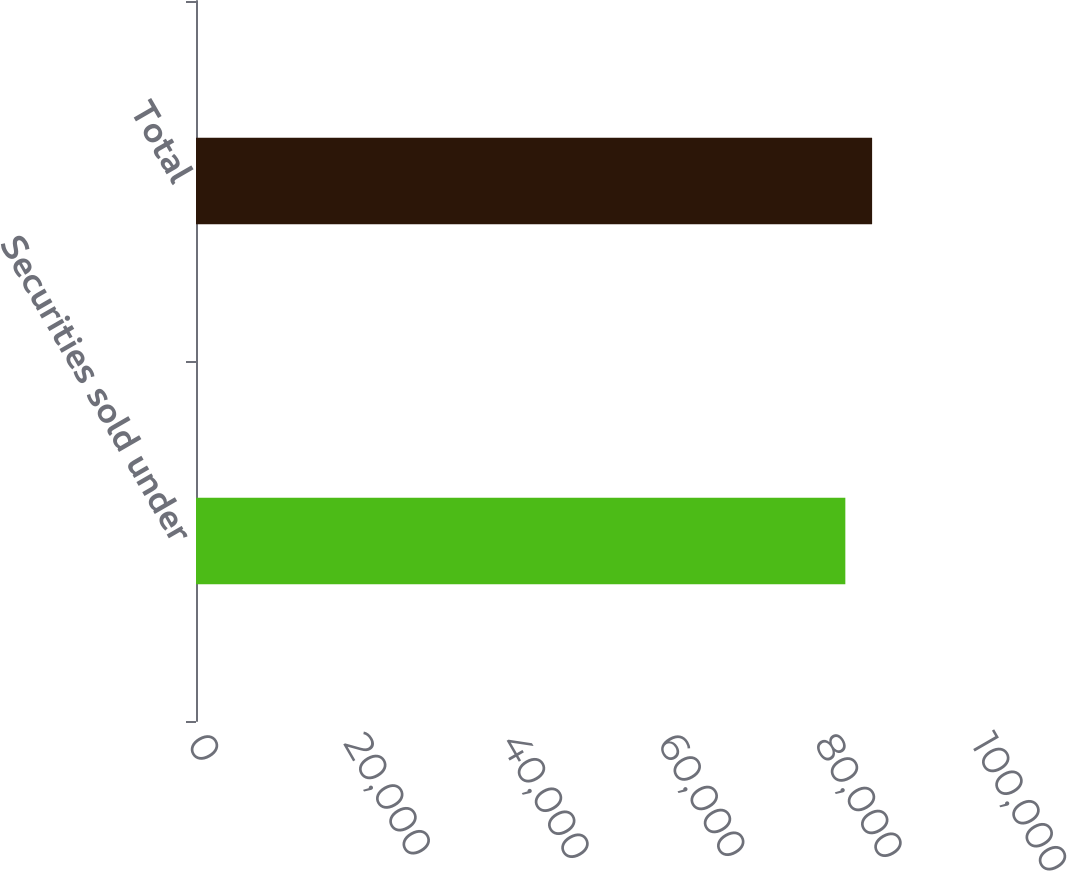<chart> <loc_0><loc_0><loc_500><loc_500><bar_chart><fcel>Securities sold under<fcel>Total<nl><fcel>82823<fcel>86238<nl></chart> 